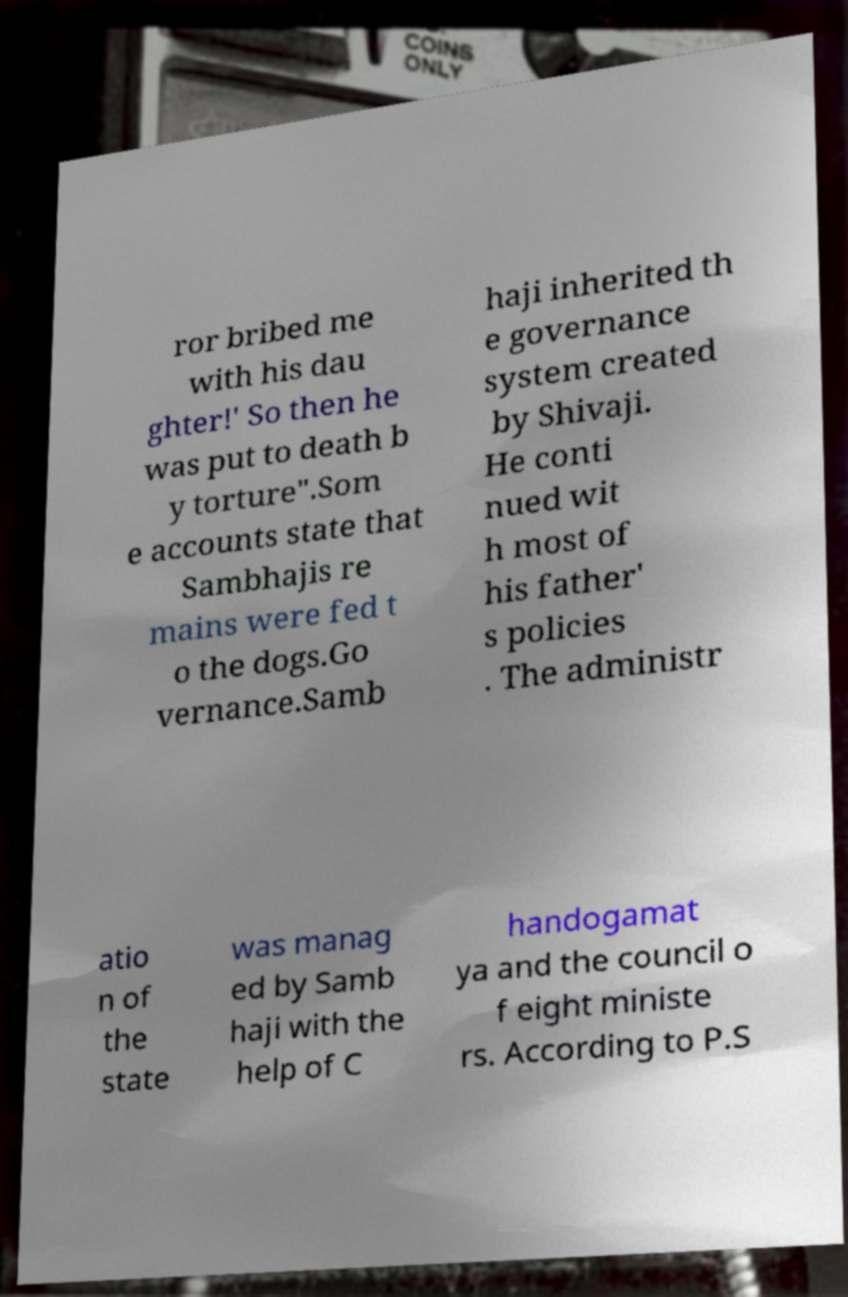There's text embedded in this image that I need extracted. Can you transcribe it verbatim? ror bribed me with his dau ghter!' So then he was put to death b y torture".Som e accounts state that Sambhajis re mains were fed t o the dogs.Go vernance.Samb haji inherited th e governance system created by Shivaji. He conti nued wit h most of his father' s policies . The administr atio n of the state was manag ed by Samb haji with the help of C handogamat ya and the council o f eight ministe rs. According to P.S 